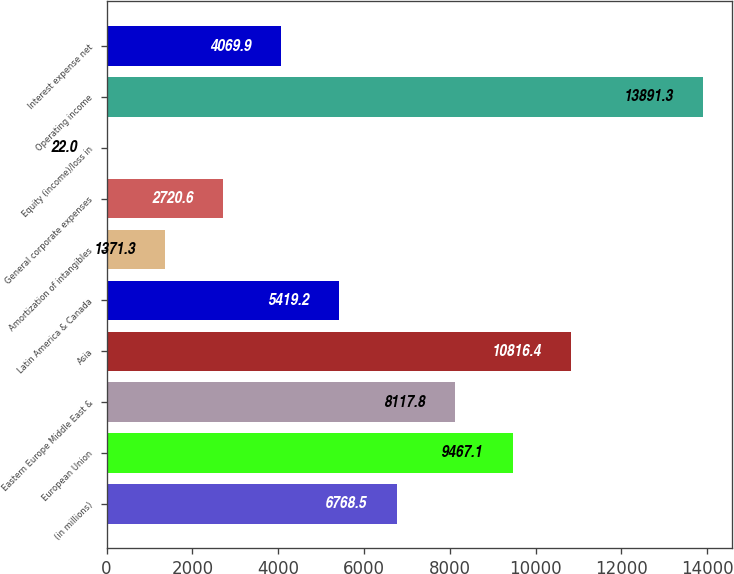Convert chart to OTSL. <chart><loc_0><loc_0><loc_500><loc_500><bar_chart><fcel>(in millions)<fcel>European Union<fcel>Eastern Europe Middle East &<fcel>Asia<fcel>Latin America & Canada<fcel>Amortization of intangibles<fcel>General corporate expenses<fcel>Equity (income)/loss in<fcel>Operating income<fcel>Interest expense net<nl><fcel>6768.5<fcel>9467.1<fcel>8117.8<fcel>10816.4<fcel>5419.2<fcel>1371.3<fcel>2720.6<fcel>22<fcel>13891.3<fcel>4069.9<nl></chart> 